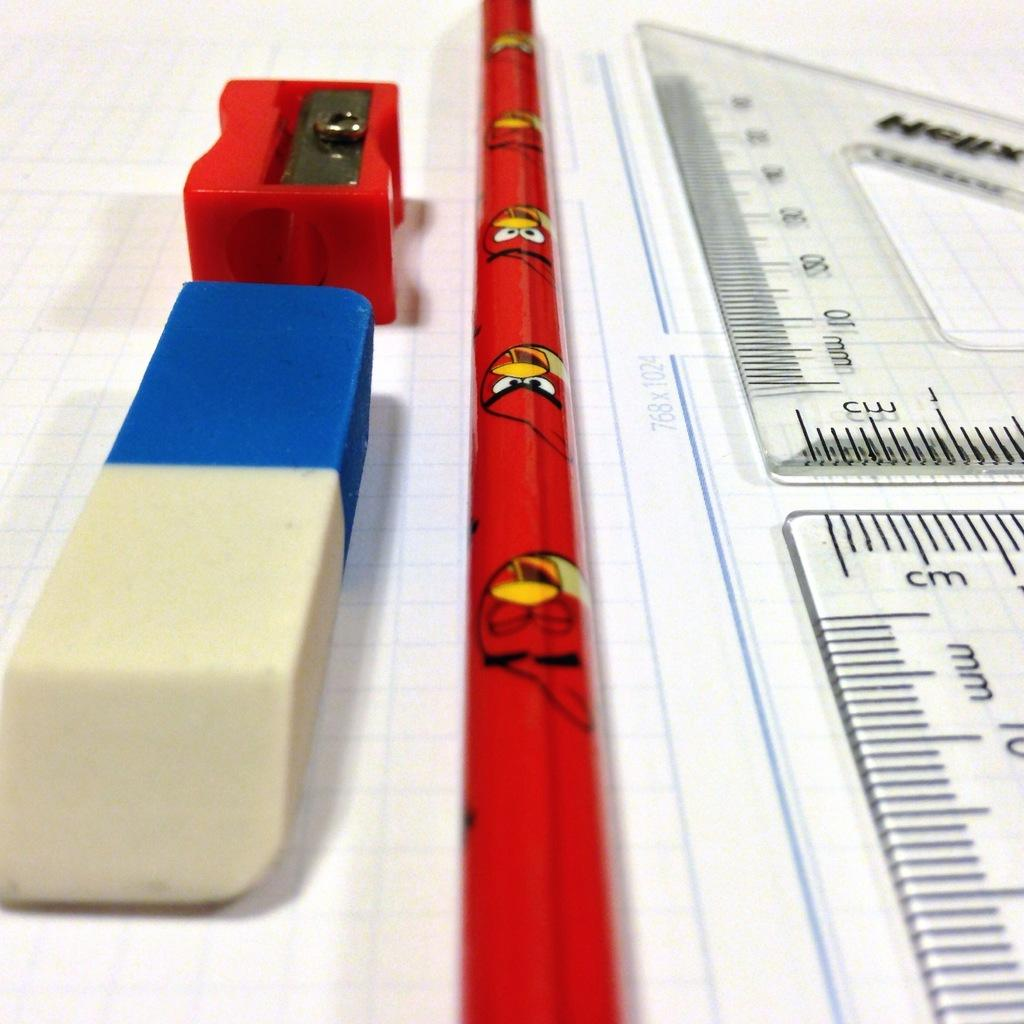<image>
Present a compact description of the photo's key features. The ruler shows measurements in cm and in mm. 